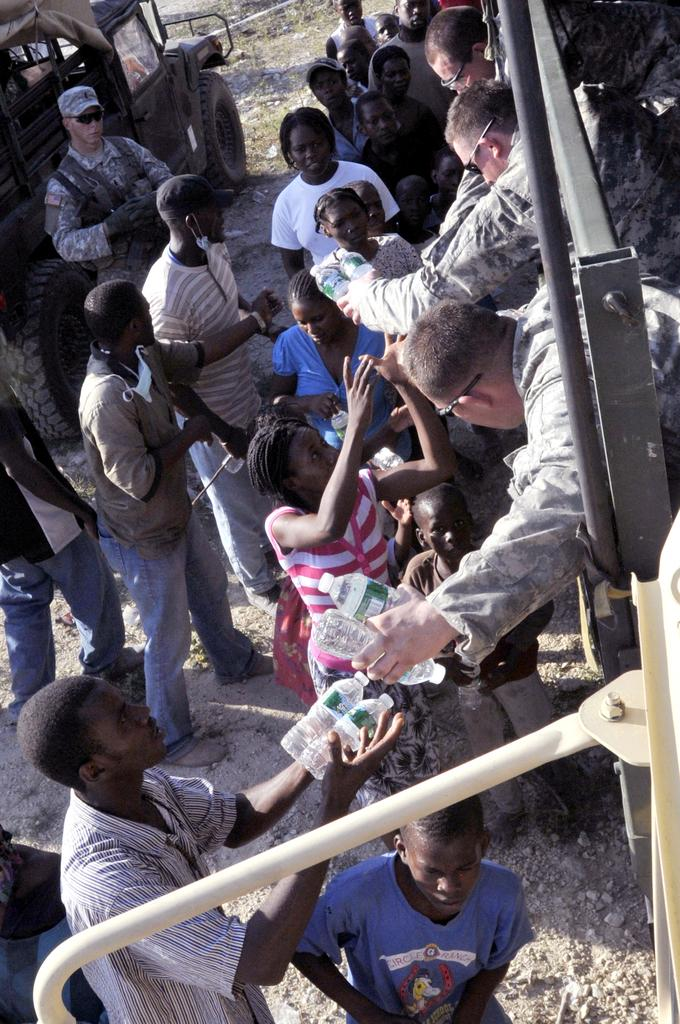How many people are present in the image? There are many people in the image. What are some of the people holding in their hands? There are people holding objects in their hands. What can be seen on the left side of the image? There is a vehicle on the left side of the image. How many fingers does the visitor have in the image? There is no visitor mentioned in the facts provided, so we cannot determine the number of fingers they might have. 